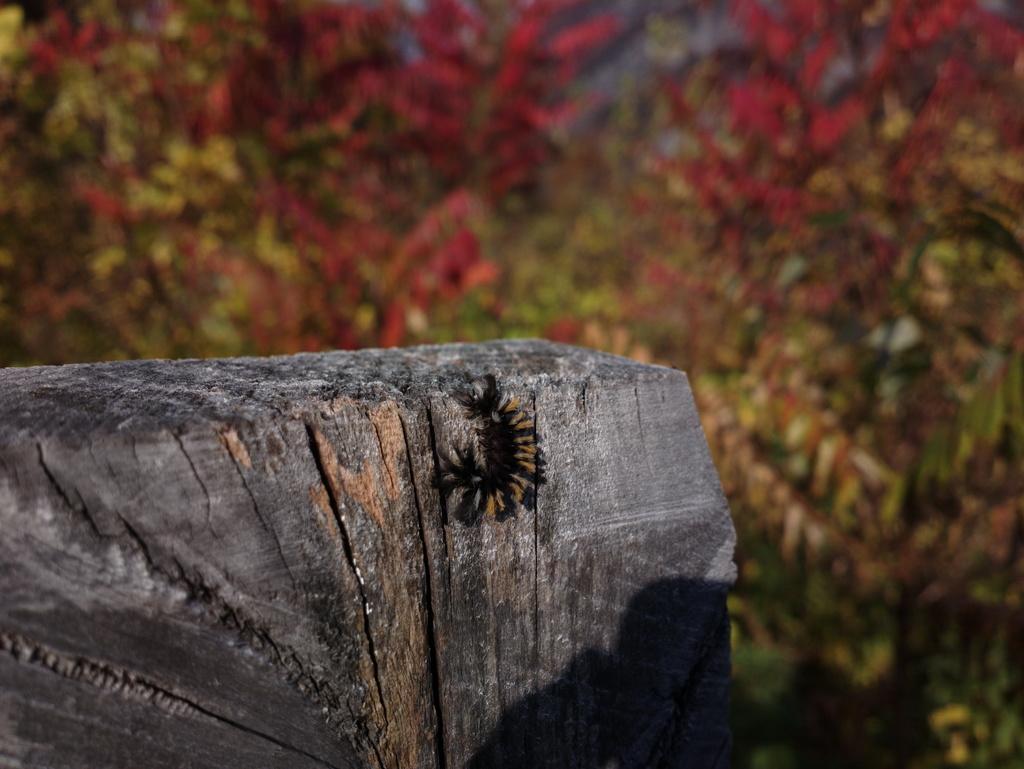Could you give a brief overview of what you see in this image? In this image we can see an insect on the wooden surface. The background of the image is blurred, where we can see trees. 